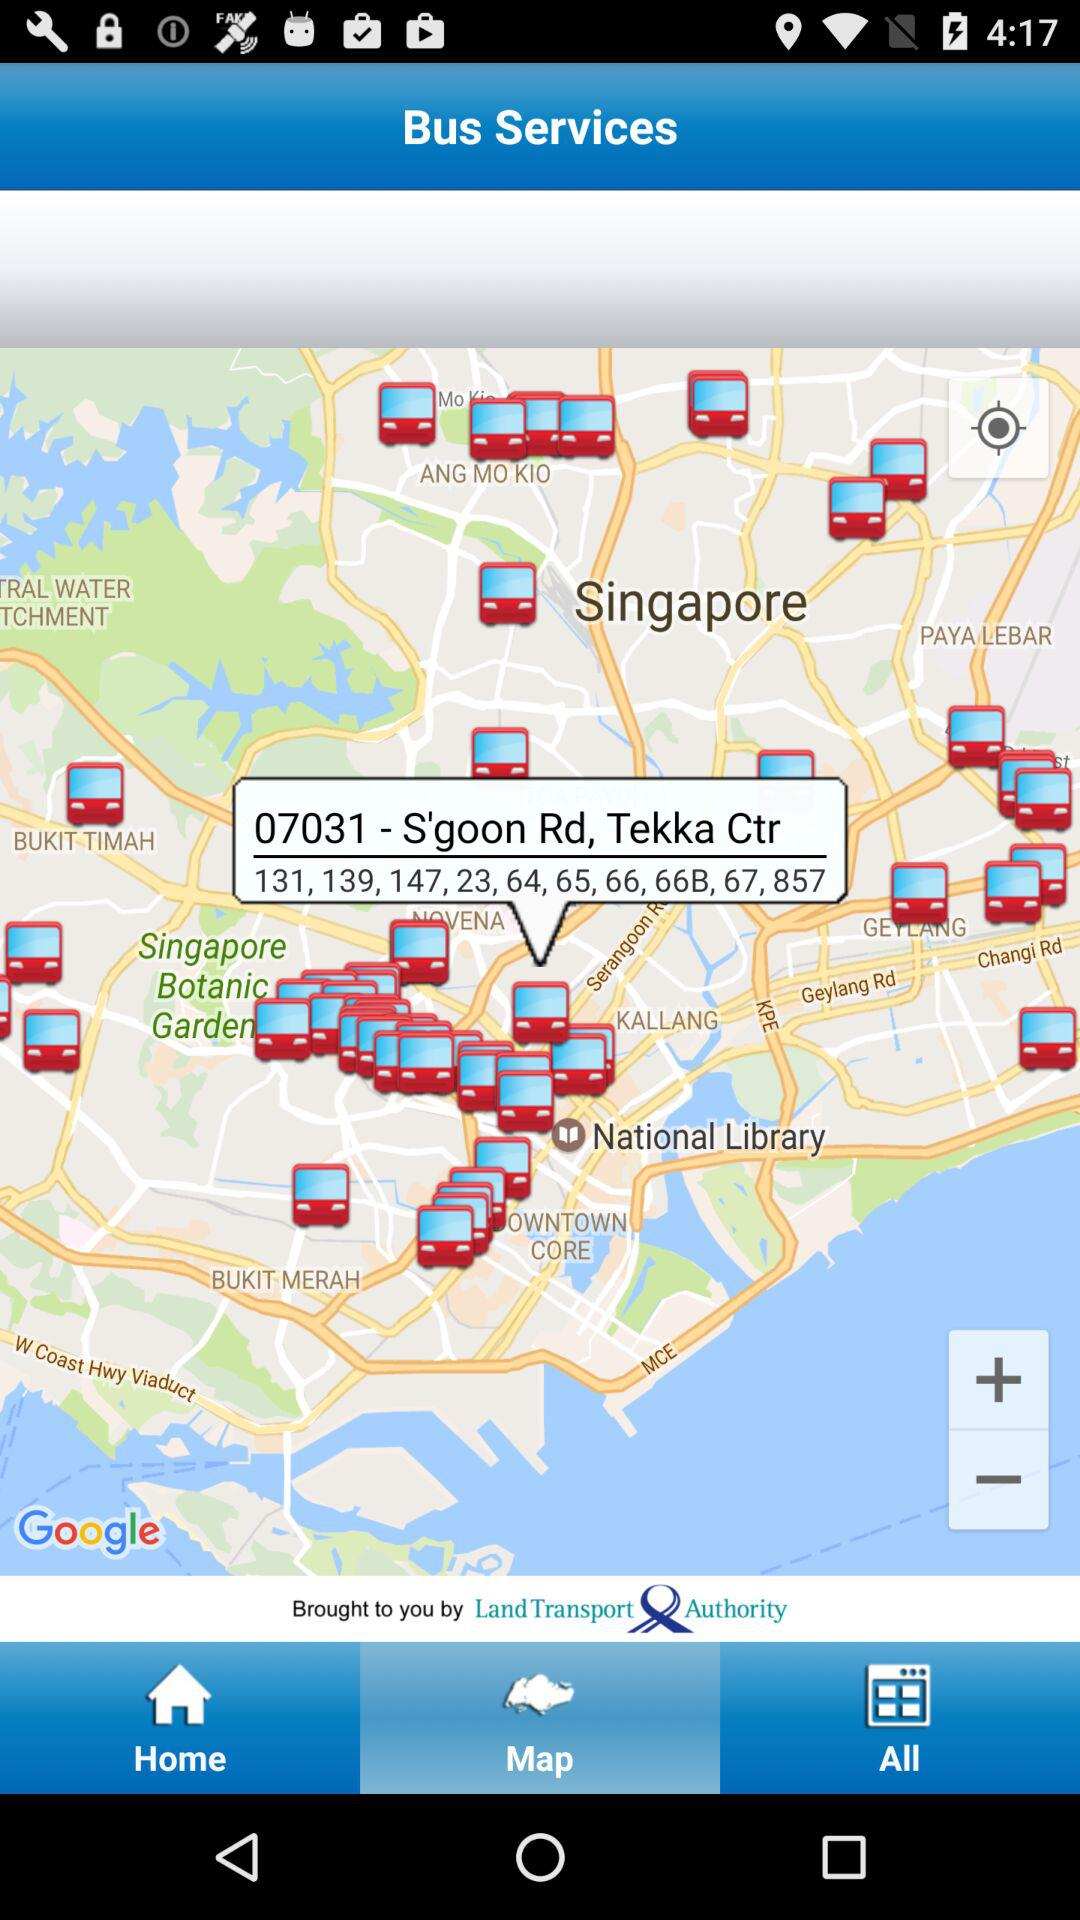It is brought to you by whom? It is brought to you by the "Land Transport Authority". 